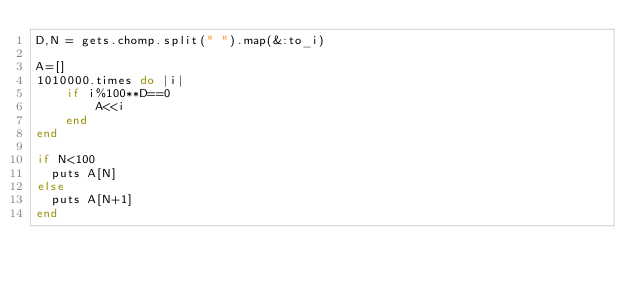<code> <loc_0><loc_0><loc_500><loc_500><_Ruby_>D,N = gets.chomp.split(" ").map(&:to_i)

A=[]
1010000.times do |i|
    if i%100**D==0
        A<<i
    end
end

if N<100
  puts A[N]
else
  puts A[N+1]
end</code> 